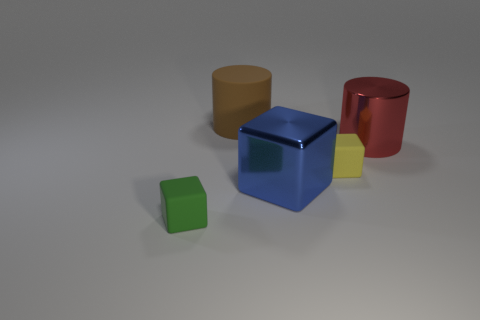Add 1 metal cubes. How many objects exist? 6 Subtract all cylinders. How many objects are left? 3 Subtract all large red cylinders. Subtract all big brown rubber cylinders. How many objects are left? 3 Add 1 green blocks. How many green blocks are left? 2 Add 3 small blocks. How many small blocks exist? 5 Subtract 0 purple cylinders. How many objects are left? 5 